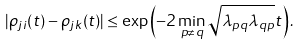Convert formula to latex. <formula><loc_0><loc_0><loc_500><loc_500>| \rho _ { j i } ( t ) - \rho _ { j k } ( t ) | \leq \exp \left ( - 2 \min _ { p \ne q } \sqrt { \lambda _ { p q } \lambda _ { q p } } t \right ) .</formula> 